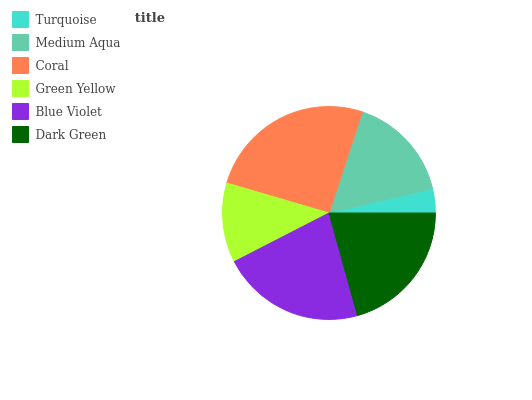Is Turquoise the minimum?
Answer yes or no. Yes. Is Coral the maximum?
Answer yes or no. Yes. Is Medium Aqua the minimum?
Answer yes or no. No. Is Medium Aqua the maximum?
Answer yes or no. No. Is Medium Aqua greater than Turquoise?
Answer yes or no. Yes. Is Turquoise less than Medium Aqua?
Answer yes or no. Yes. Is Turquoise greater than Medium Aqua?
Answer yes or no. No. Is Medium Aqua less than Turquoise?
Answer yes or no. No. Is Dark Green the high median?
Answer yes or no. Yes. Is Medium Aqua the low median?
Answer yes or no. Yes. Is Blue Violet the high median?
Answer yes or no. No. Is Turquoise the low median?
Answer yes or no. No. 